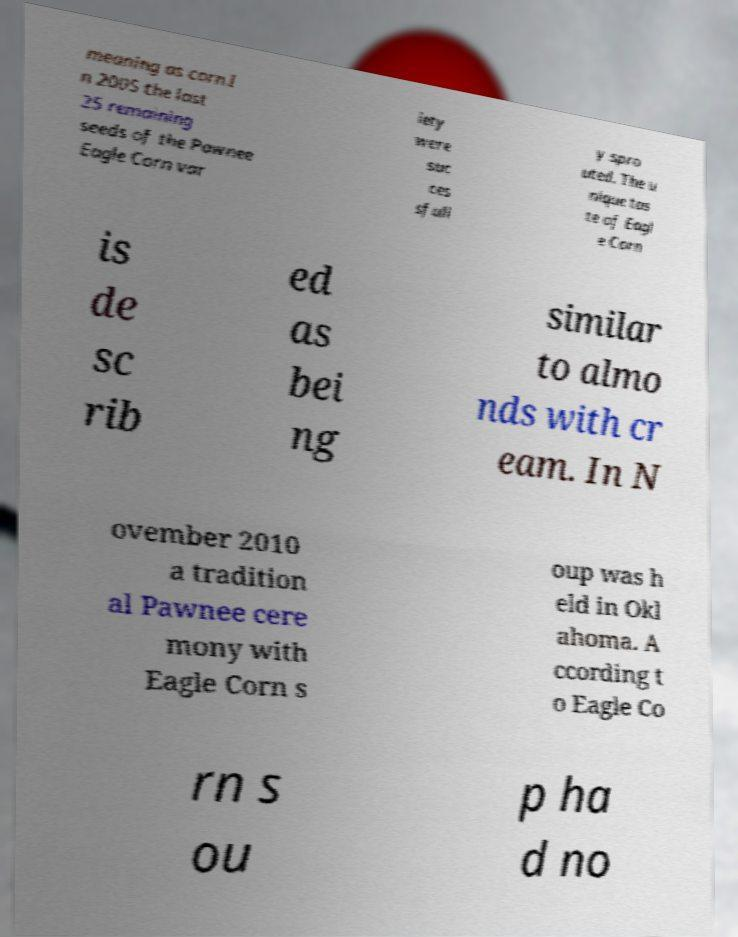Could you extract and type out the text from this image? meaning as corn.I n 2005 the last 25 remaining seeds of the Pawnee Eagle Corn var iety were suc ces sfull y spro uted. The u nique tas te of Eagl e Corn is de sc rib ed as bei ng similar to almo nds with cr eam. In N ovember 2010 a tradition al Pawnee cere mony with Eagle Corn s oup was h eld in Okl ahoma. A ccording t o Eagle Co rn s ou p ha d no 